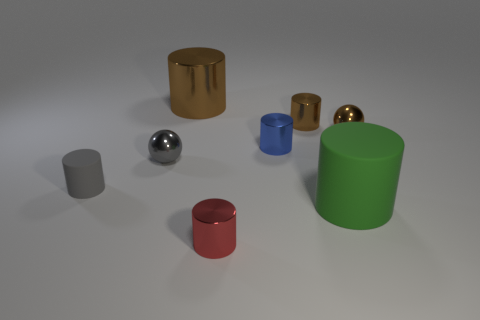Subtract all red metallic cylinders. How many cylinders are left? 5 Subtract all gray cylinders. How many cylinders are left? 5 Subtract 3 cylinders. How many cylinders are left? 3 Subtract all gray cylinders. Subtract all yellow cubes. How many cylinders are left? 5 Add 2 gray things. How many objects exist? 10 Subtract all cylinders. How many objects are left? 2 Subtract all yellow cubes. Subtract all metal cylinders. How many objects are left? 4 Add 5 gray cylinders. How many gray cylinders are left? 6 Add 6 gray metal spheres. How many gray metal spheres exist? 7 Subtract 1 red cylinders. How many objects are left? 7 